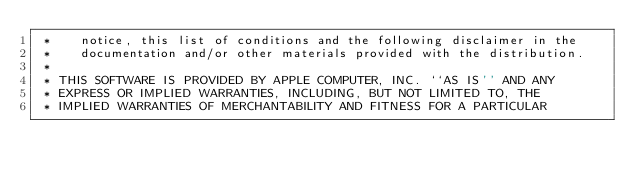Convert code to text. <code><loc_0><loc_0><loc_500><loc_500><_ObjectiveC_> *    notice, this list of conditions and the following disclaimer in the
 *    documentation and/or other materials provided with the distribution.
 *
 * THIS SOFTWARE IS PROVIDED BY APPLE COMPUTER, INC. ``AS IS'' AND ANY
 * EXPRESS OR IMPLIED WARRANTIES, INCLUDING, BUT NOT LIMITED TO, THE
 * IMPLIED WARRANTIES OF MERCHANTABILITY AND FITNESS FOR A PARTICULAR</code> 